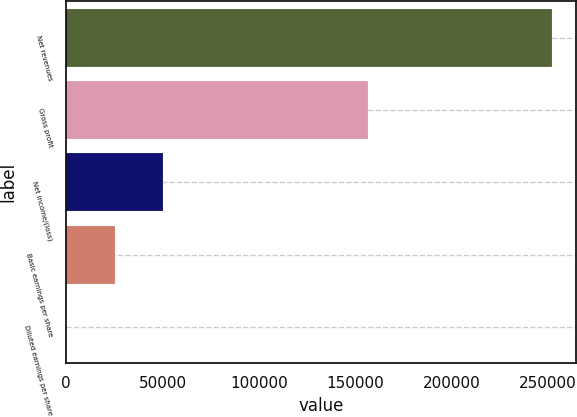Convert chart to OTSL. <chart><loc_0><loc_0><loc_500><loc_500><bar_chart><fcel>Net revenues<fcel>Gross profit<fcel>Net income/(loss)<fcel>Basic earnings per share<fcel>Diluted earnings per share<nl><fcel>251959<fcel>156708<fcel>50392.3<fcel>25196.4<fcel>0.59<nl></chart> 